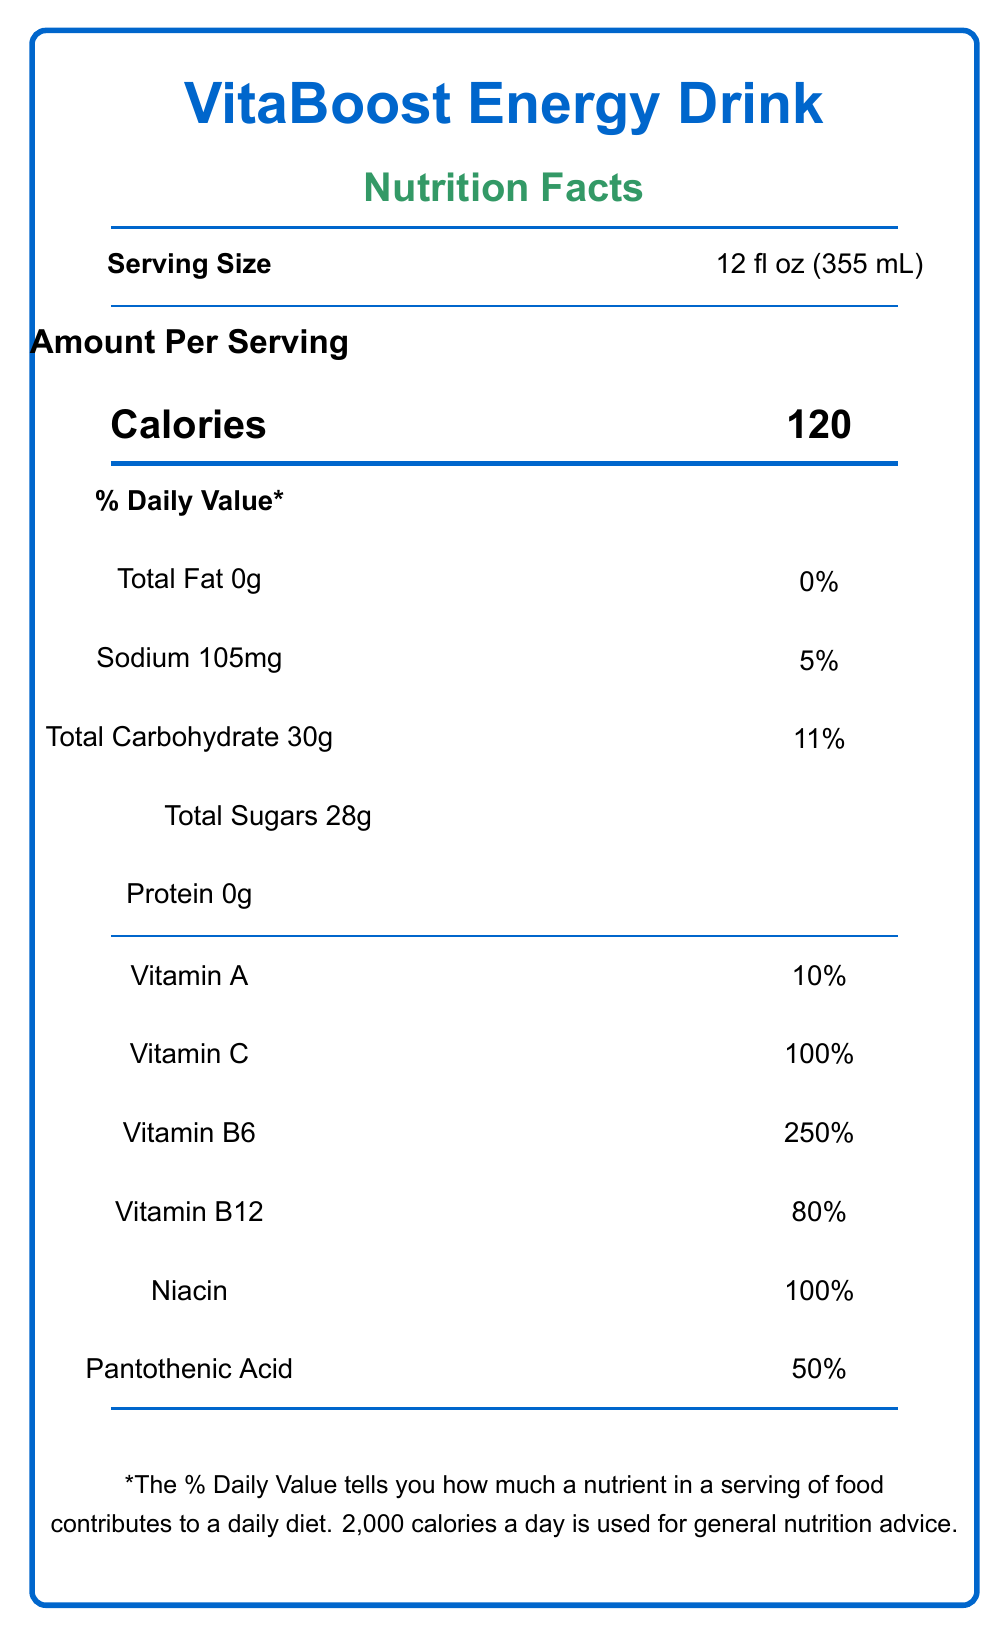what is the serving size of the VitaBoost Energy Drink? The serving size is indicated at the top of the document next to "Serving Size".
Answer: 12 fl oz (355 mL) how many calories are there per serving? The number of calories per serving is displayed prominently in the "Amount Per Serving" section next to "Calories".
Answer: 120 what percentage of the daily value (DV) of Vitamin C does one serving provide? The document states that Vitamin C provides 100% of the Daily Value per serving.
Answer: 100% DV does the VitaBoost Energy Drink contain any fat? The document lists "Total Fat 0g" with 0% Daily Value, indicating there is no fat in the drink.
Answer: No how much sodium is in one serving of this beverage? The sodium content is listed in the "Amount Per Serving" section as "Sodium 105mg".
Answer: 105mg which vitamin has the highest percentage of daily value in the drink? A. Vitamin A B. Vitamin C C. Vitamin B6 D. Pantothenic Acid The document shows that Vitamin B6 has a 250% Daily Value, the highest among the vitamins listed.
Answer: C. Vitamin B6 how much caffeine does the VitaBoost Energy Drink contain? A. 100mg B. 120mg C. 150mg D. 180mg The amount of caffeine listed in the document is 150mg.
Answer: C. 150mg what is the customer retention rate of the VitaBoost Energy Drink? The customer retention rate is part of the key performance indicators section and is listed as 68%.
Answer: 68% does the VitaBoost Energy Drink contain Vitamin D? The document does not list Vitamin D among the nutrients provided, so it can be inferred that Vitamin D is not included in the drink.
Answer: No summarize the main highlights of the VitaBoost Energy Drink’s nutritional and demographic information. The VitaBoost Energy Drink provides significant vitamin content and various functional ingredients. Key performance indicators suggest moderate market success, and the consumer demographic data highlights the primary market segments for the product.
Answer: The VitaBoost Energy Drink offers substantial vitamins including high levels of Vitamin C (100% DV) and Vitamin B6 (250% DV), along with additional ingredients such as caffeine (150mg) and taurine (1000mg). The drink contains 120 calories per serving with 28g of total sugars. Key performance indicators include an 8.3% market share and 68% customer retention rate, while consumer demographics show a strong presence in the 18-34 age group and a gender distribution of 58% male, 41% female, and 1% non-binary. what is the most common purchase location for the VitaBoost Energy Drink? The document indicates that 45% of purchases occur in convenience stores, making it the most common purchase location.
Answer: Convenience stores how does the number of calories in VitaBoost Energy Drink compare to other energy drinks? The document provides the calorie count for VitaBoost Energy Drink but does not provide comparative data for other energy drinks.
Answer: Not enough information what percentage of the consumer base is aged between 25-34? A. 35% B. 42% C. 18% D. 5% The age group distribution section notes that 42% of consumers fall within the 25-34 age range.
Answer: B. 42% do grocery stores account for a larger percentage of purchases than fitness centers? Grocery stores account for 30% of purchases, whereas fitness centers account for 10%.
Answer: Yes 